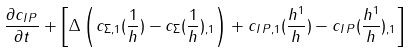<formula> <loc_0><loc_0><loc_500><loc_500>\frac { \partial c _ { I \, P } } { \partial t } + \left [ \Delta \left ( c _ { \Sigma , 1 } ( \frac { 1 } { h } ) - c _ { \Sigma } ( \frac { 1 } { h } ) _ { , 1 } \right ) + c _ { I \, P , 1 } ( \frac { h ^ { 1 } } { h } ) - c _ { I \, P } ( \frac { h ^ { 1 } } { h } ) _ { , 1 } \right ]</formula> 